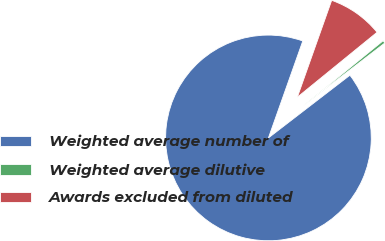Convert chart to OTSL. <chart><loc_0><loc_0><loc_500><loc_500><pie_chart><fcel>Weighted average number of<fcel>Weighted average dilutive<fcel>Awards excluded from diluted<nl><fcel>90.86%<fcel>0.44%<fcel>8.7%<nl></chart> 